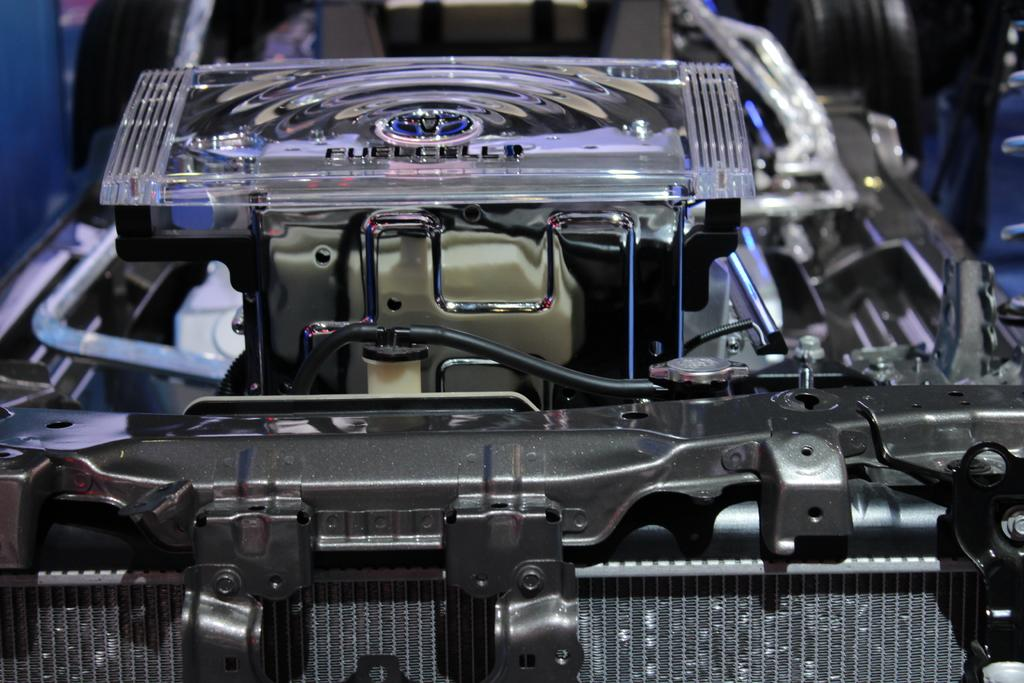What is the main subject of the picture? The main subject of the picture is a vehicle engine. What are some features of the engine? The engine has wires and a glass fuel cell on top of it. What is the value of the zephyr in the image? There is no zephyr present in the image, so it does not have a value. 